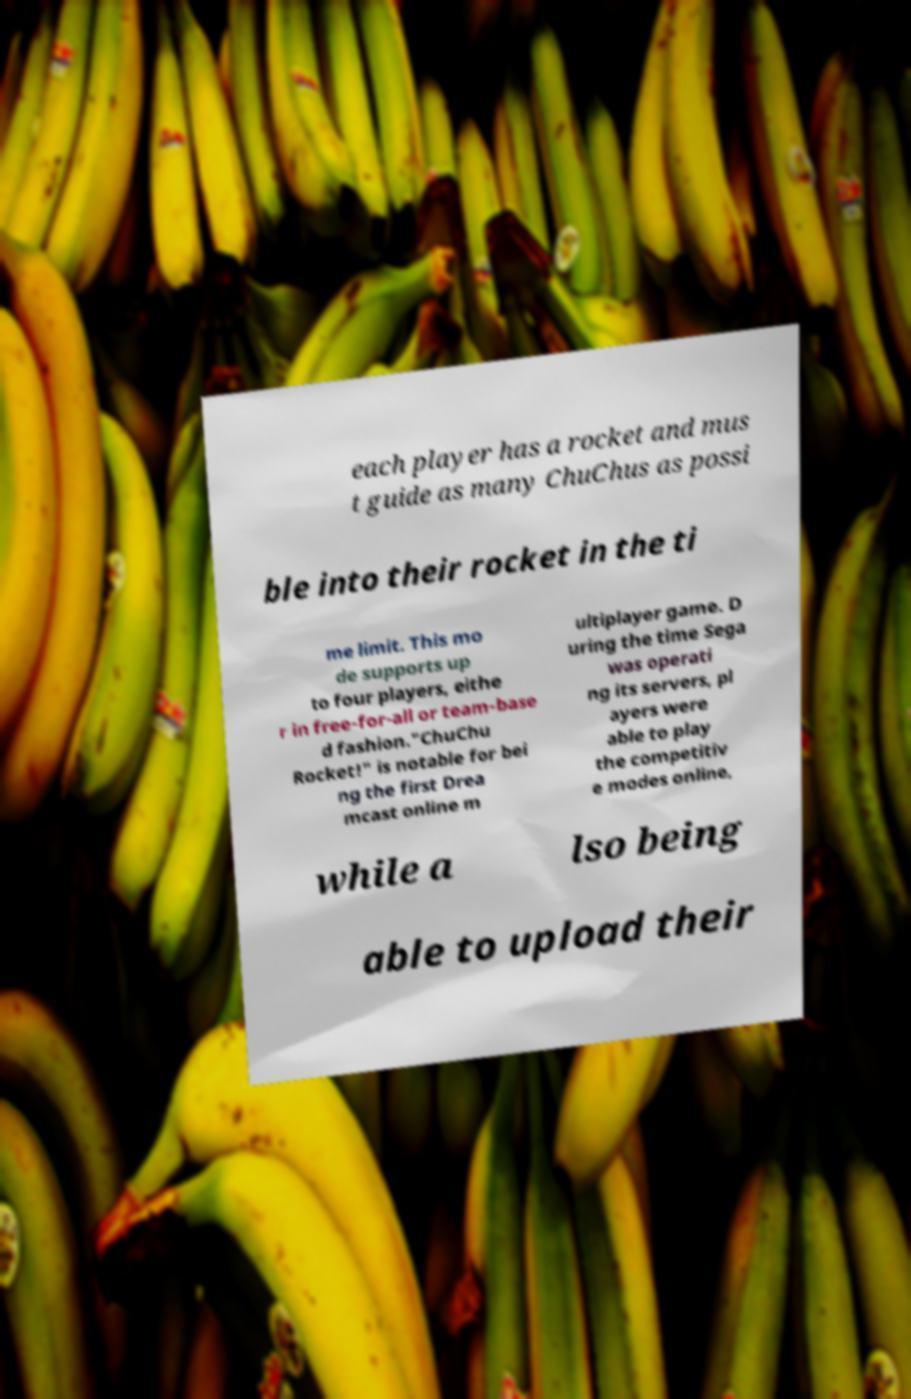Can you read and provide the text displayed in the image?This photo seems to have some interesting text. Can you extract and type it out for me? each player has a rocket and mus t guide as many ChuChus as possi ble into their rocket in the ti me limit. This mo de supports up to four players, eithe r in free-for-all or team-base d fashion."ChuChu Rocket!" is notable for bei ng the first Drea mcast online m ultiplayer game. D uring the time Sega was operati ng its servers, pl ayers were able to play the competitiv e modes online, while a lso being able to upload their 